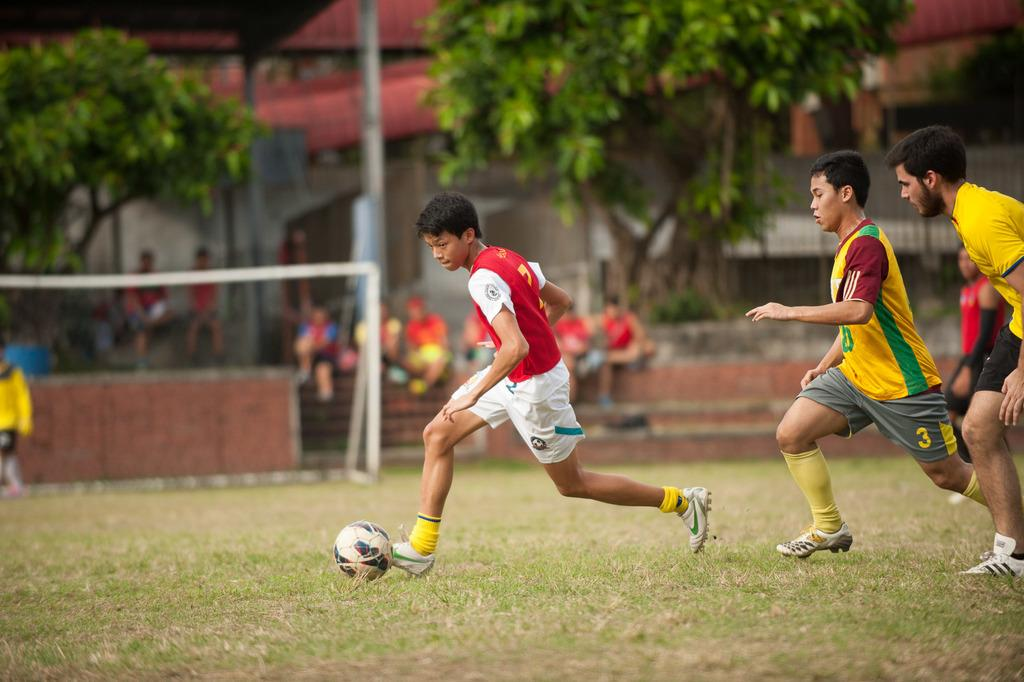<image>
Provide a brief description of the given image. Three young men playing soccer with one man dressed in red and white kicking the ball while the other two men chase him. 